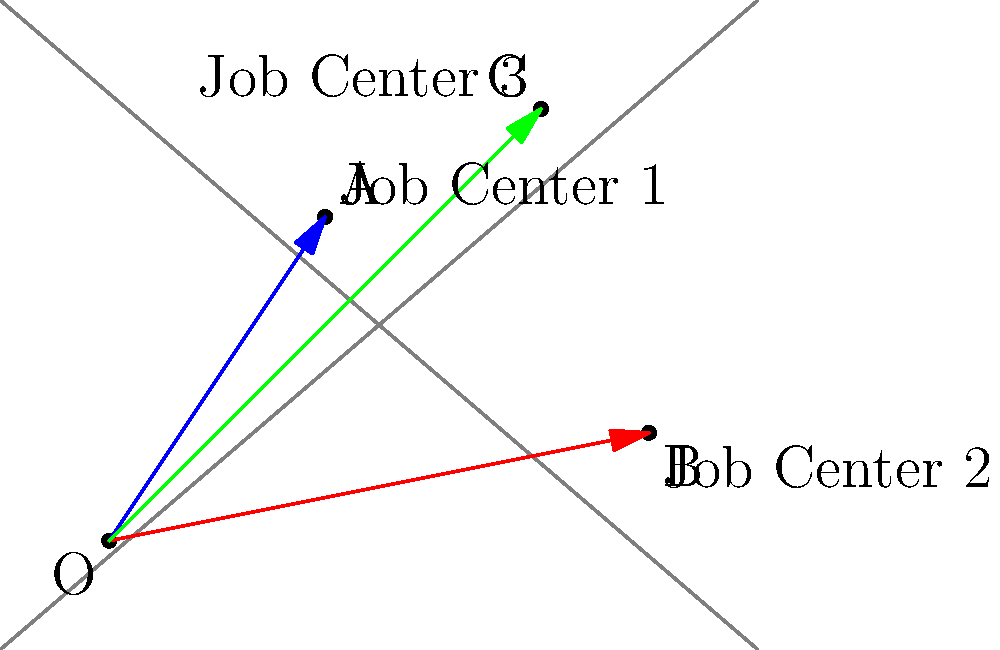A map shows the locations of three job centers that offer employment opportunities for ex-offenders. The positions of these centers are represented by vectors from the origin O. Job Center 1 is at $\vec{a} = 2\hat{i} + 3\hat{j}$, Job Center 2 is at $\vec{b} = 5\hat{i} + \hat{j}$, and Job Center 3 is at $\vec{c} = 4\hat{i} + 4\hat{j}$. Which job center is closest to the midpoint between the other two centers? To solve this problem, we need to follow these steps:

1) First, let's find the midpoint between Job Centers 1 and 2:
   Midpoint = $\frac{1}{2}(\vec{a} + \vec{b}) = \frac{1}{2}((2\hat{i} + 3\hat{j}) + (5\hat{i} + \hat{j})) = \frac{1}{2}(7\hat{i} + 4\hat{j}) = 3.5\hat{i} + 2\hat{j}$

2) Now, let's find the midpoint between Job Centers 1 and 3:
   Midpoint = $\frac{1}{2}(\vec{a} + \vec{c}) = \frac{1}{2}((2\hat{i} + 3\hat{j}) + (4\hat{i} + 4\hat{j})) = \frac{1}{2}(6\hat{i} + 7\hat{j}) = 3\hat{i} + 3.5\hat{j}$

3) Finally, let's find the midpoint between Job Centers 2 and 3:
   Midpoint = $\frac{1}{2}(\vec{b} + \vec{c}) = \frac{1}{2}((5\hat{i} + \hat{j}) + (4\hat{i} + 4\hat{j})) = \frac{1}{2}(9\hat{i} + 5\hat{j}) = 4.5\hat{i} + 2.5\hat{j}$

4) Now, we need to compare the distance between each job center and these midpoints:

   For Job Center 1 ($\vec{a} = 2\hat{i} + 3\hat{j}$):
   - Distance to midpoint of 2 and 3: $|\vec{a} - (4.5\hat{i} + 2.5\hat{j})| = |(-2.5\hat{i} + 0.5\hat{j})| = \sqrt{(-2.5)^2 + 0.5^2} = 2.55$

   For Job Center 2 ($\vec{b} = 5\hat{i} + \hat{j}$):
   - Distance to midpoint of 1 and 3: $|\vec{b} - (3\hat{i} + 3.5\hat{j})| = |(2\hat{i} - 2.5\hat{j})| = \sqrt{2^2 + (-2.5)^2} = 3.20$

   For Job Center 3 ($\vec{c} = 4\hat{i} + 4\hat{j}$):
   - Distance to midpoint of 1 and 2: $|\vec{c} - (3.5\hat{i} + 2\hat{j})| = |(0.5\hat{i} + 2\hat{j})| = \sqrt{0.5^2 + 2^2} = 2.06$

5) The smallest distance is 2.06, which corresponds to Job Center 3.
Answer: Job Center 3 